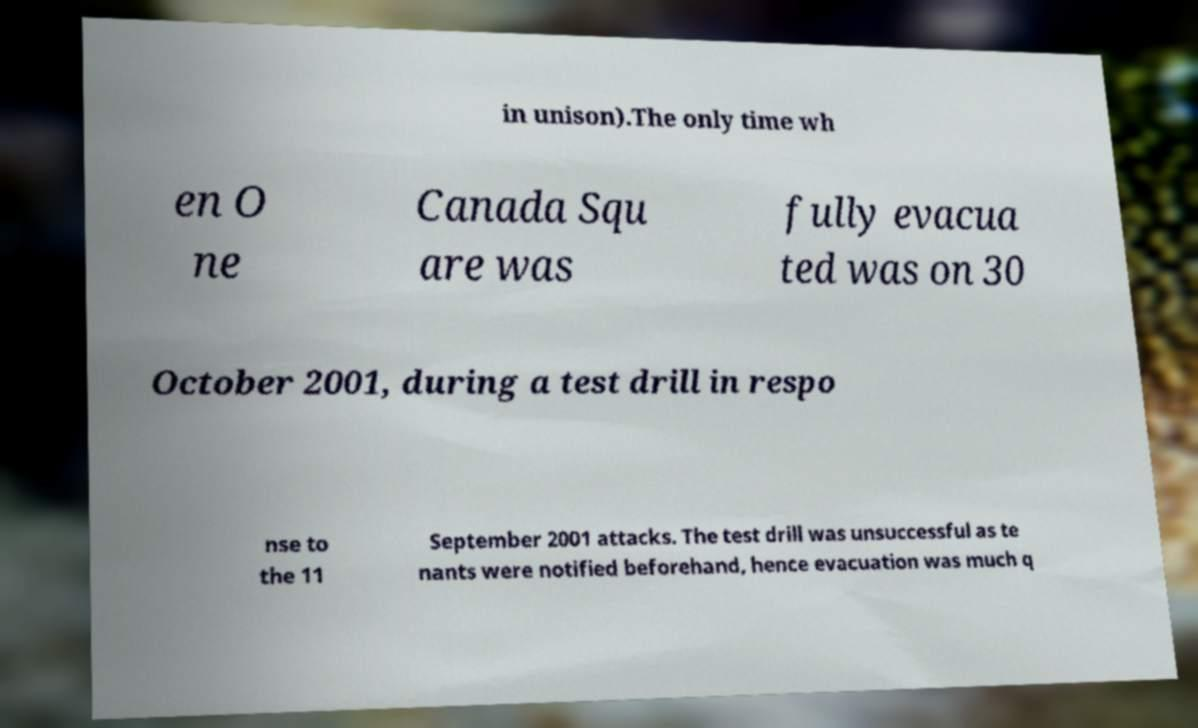Can you accurately transcribe the text from the provided image for me? in unison).The only time wh en O ne Canada Squ are was fully evacua ted was on 30 October 2001, during a test drill in respo nse to the 11 September 2001 attacks. The test drill was unsuccessful as te nants were notified beforehand, hence evacuation was much q 